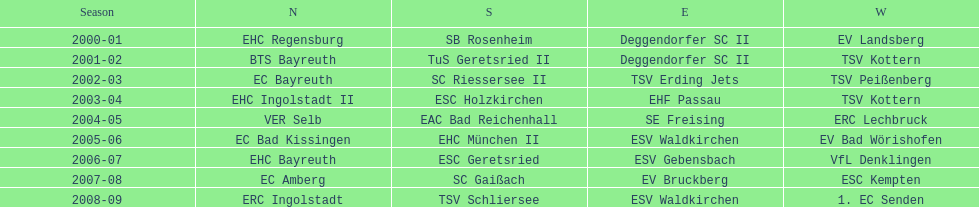Who won the season in the north before ec bayreuth did in 2002-03? BTS Bayreuth. 